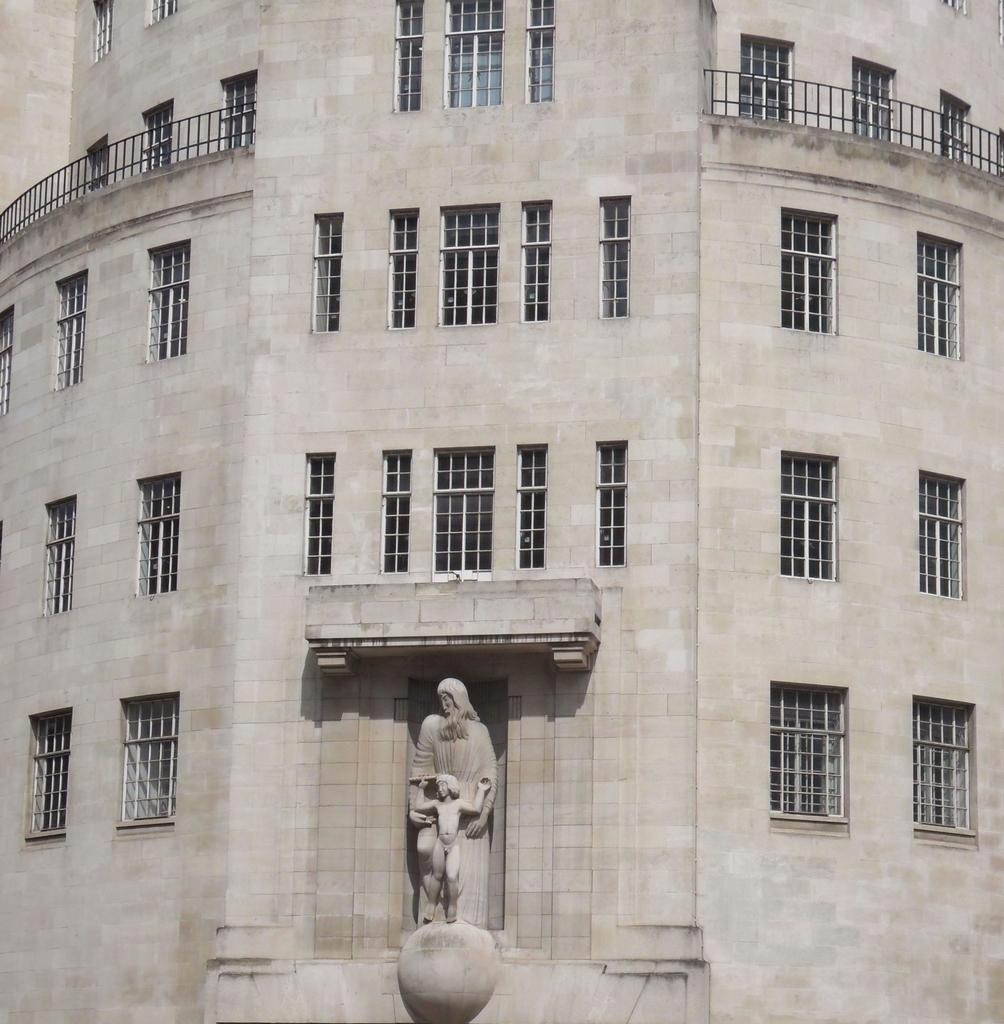What is the main subject in the image? There is a statue in the image. Where is the statue located in relation to the building? The statue is near a building. Can you describe the building in the image? The building has many windows and railing, and it is in an ash color. Is the farmer driving the statue in the image? There is no farmer or driving activity present in the image. The statue is stationary near the building. 